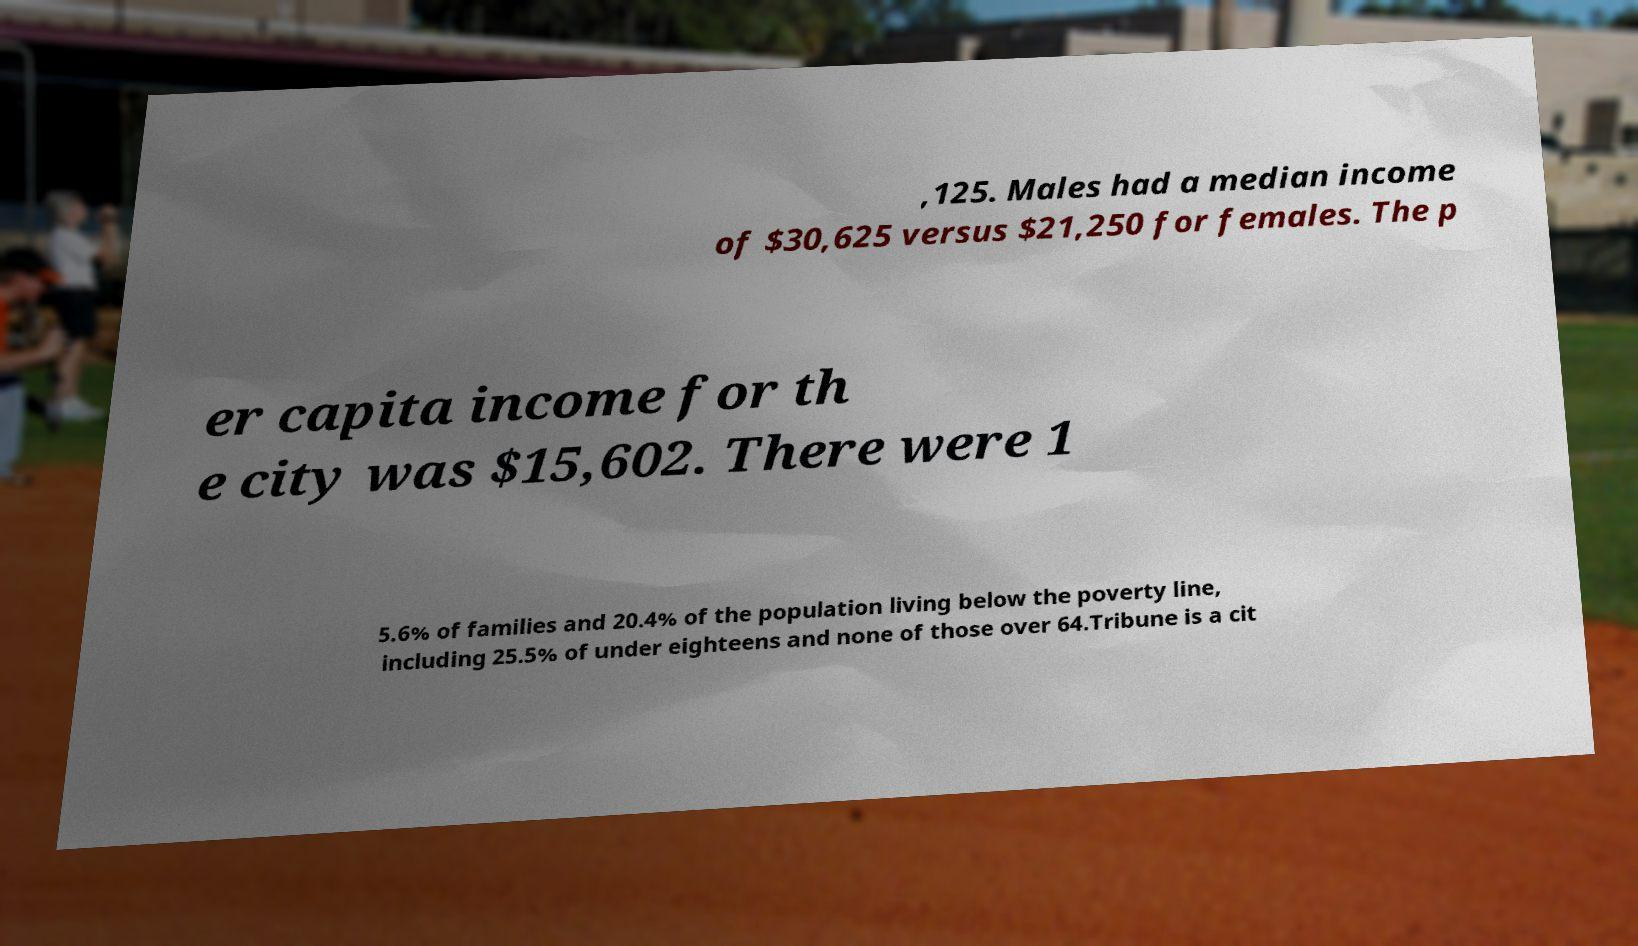Could you assist in decoding the text presented in this image and type it out clearly? ,125. Males had a median income of $30,625 versus $21,250 for females. The p er capita income for th e city was $15,602. There were 1 5.6% of families and 20.4% of the population living below the poverty line, including 25.5% of under eighteens and none of those over 64.Tribune is a cit 